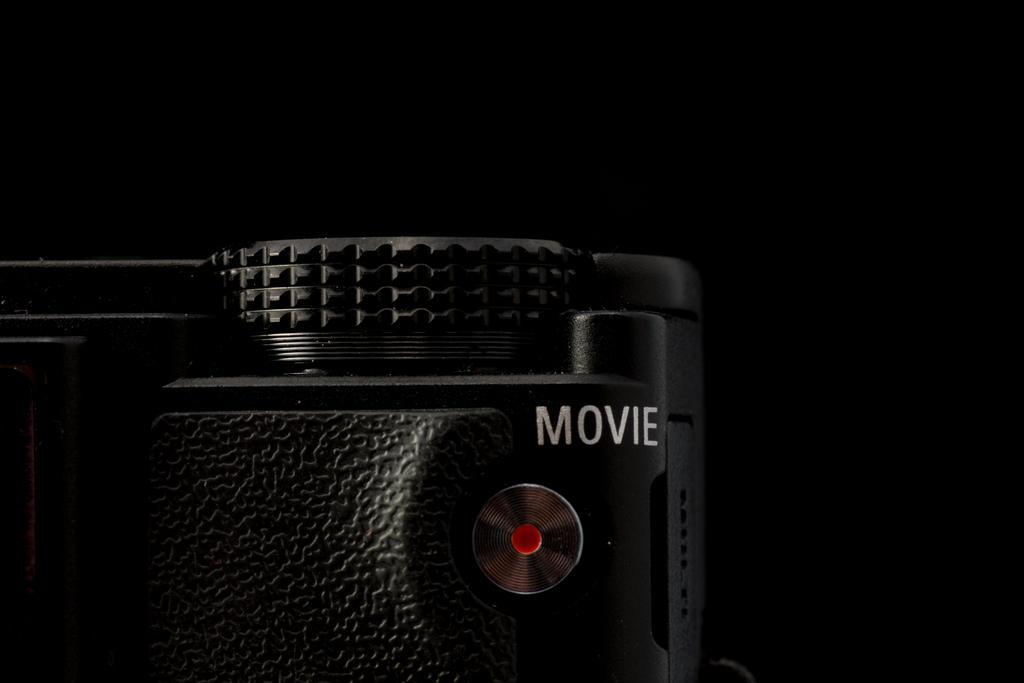Describe this image in one or two sentences. In the image there is a camera in the front and the background is black. 